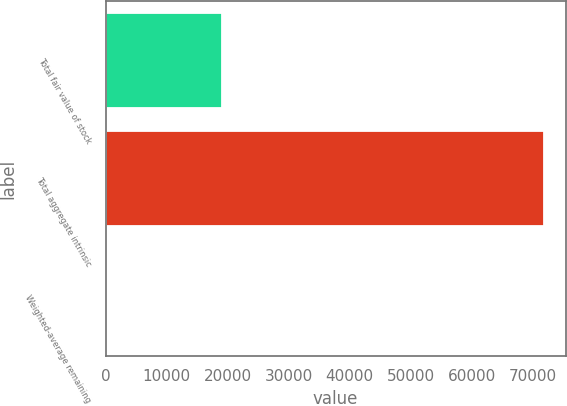Convert chart. <chart><loc_0><loc_0><loc_500><loc_500><bar_chart><fcel>Total fair value of stock<fcel>Total aggregate intrinsic<fcel>Weighted-average remaining<nl><fcel>19066<fcel>71783<fcel>3.87<nl></chart> 